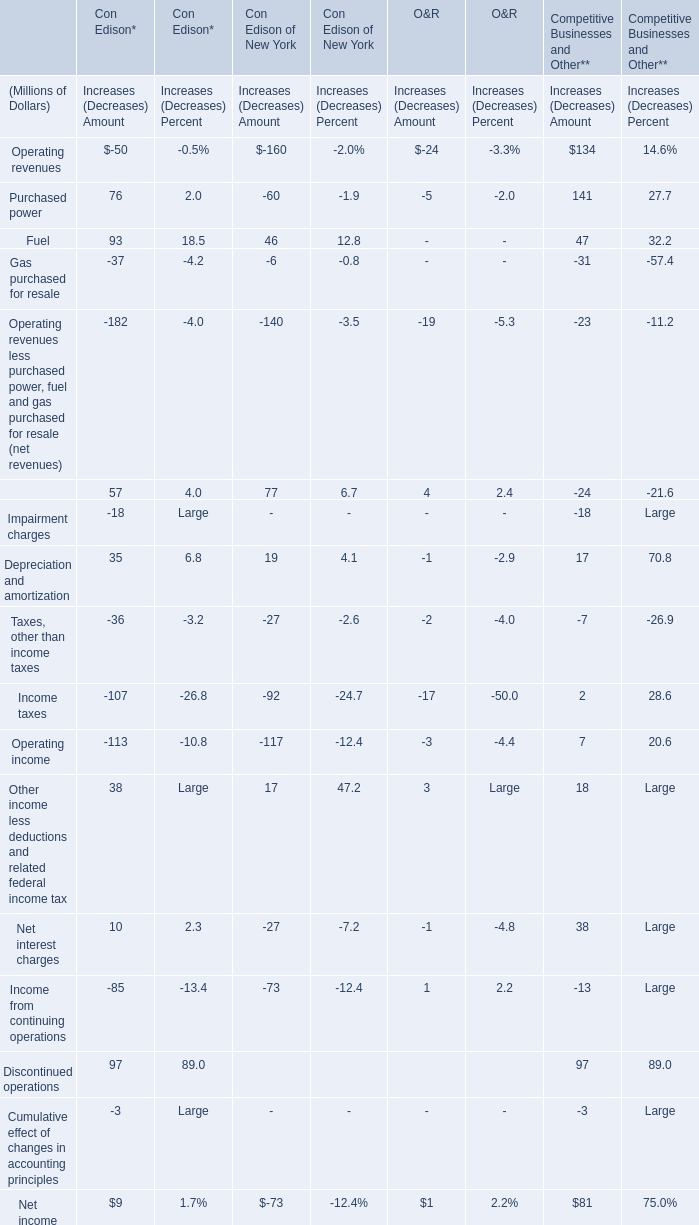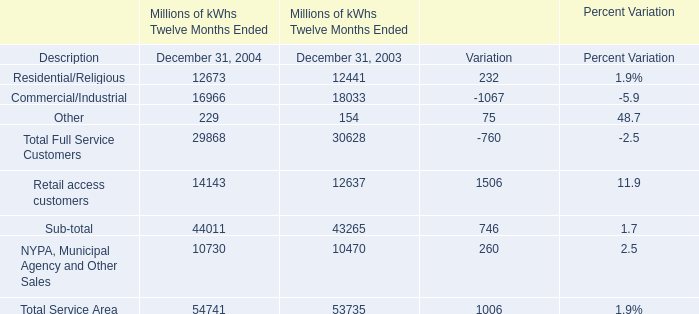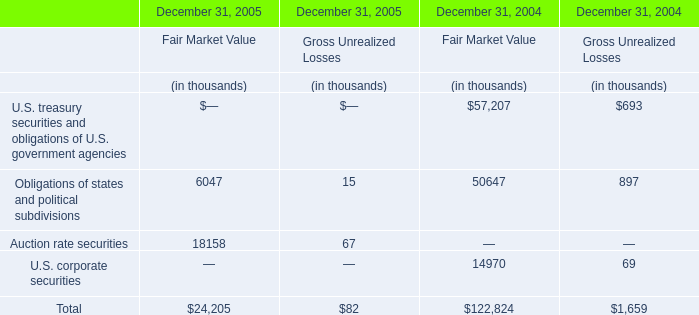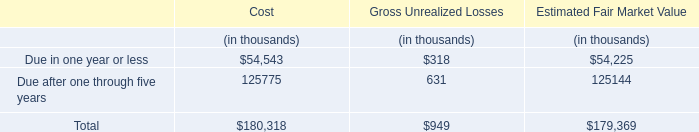In the year with the most Obligations of states and political subdivisions of Fair Market Value in Table 2, what is the growth rate of Other in Table 1? 
Computations: ((229 - 154) / 154)
Answer: 0.48701. 